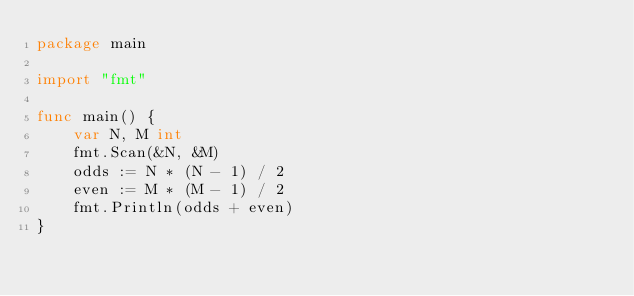<code> <loc_0><loc_0><loc_500><loc_500><_Go_>package main

import "fmt"

func main() {
	var N, M int
	fmt.Scan(&N, &M)
	odds := N * (N - 1) / 2
	even := M * (M - 1) / 2
	fmt.Println(odds + even)
}
</code> 